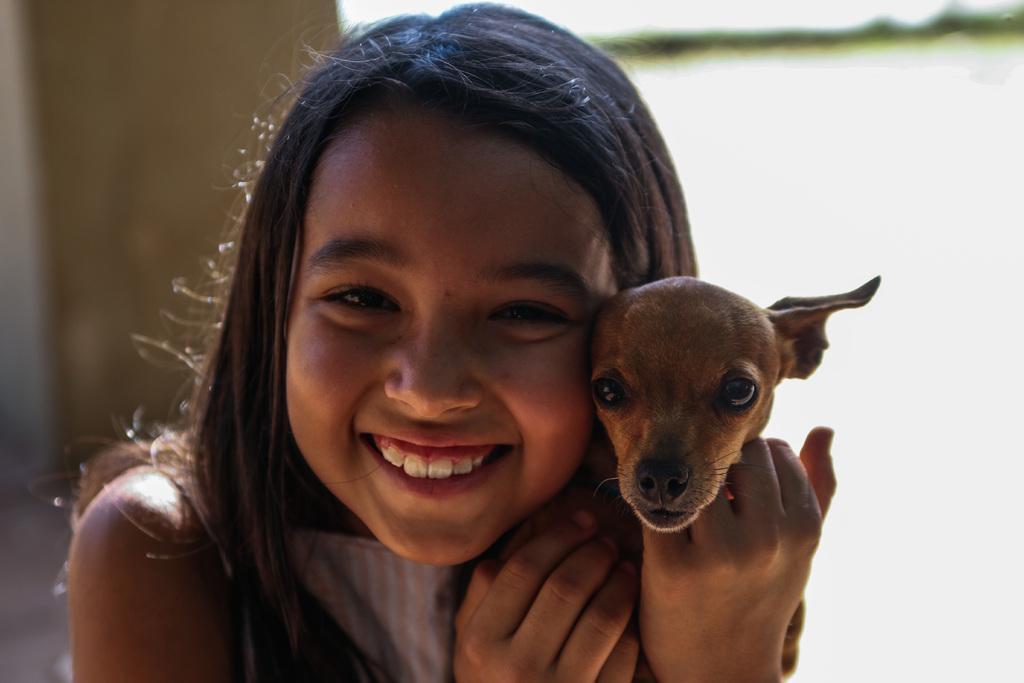In one or two sentences, can you explain what this image depicts? In this picture there is a small girl smiling and she has a puppy in hands and in the background there is a wall 